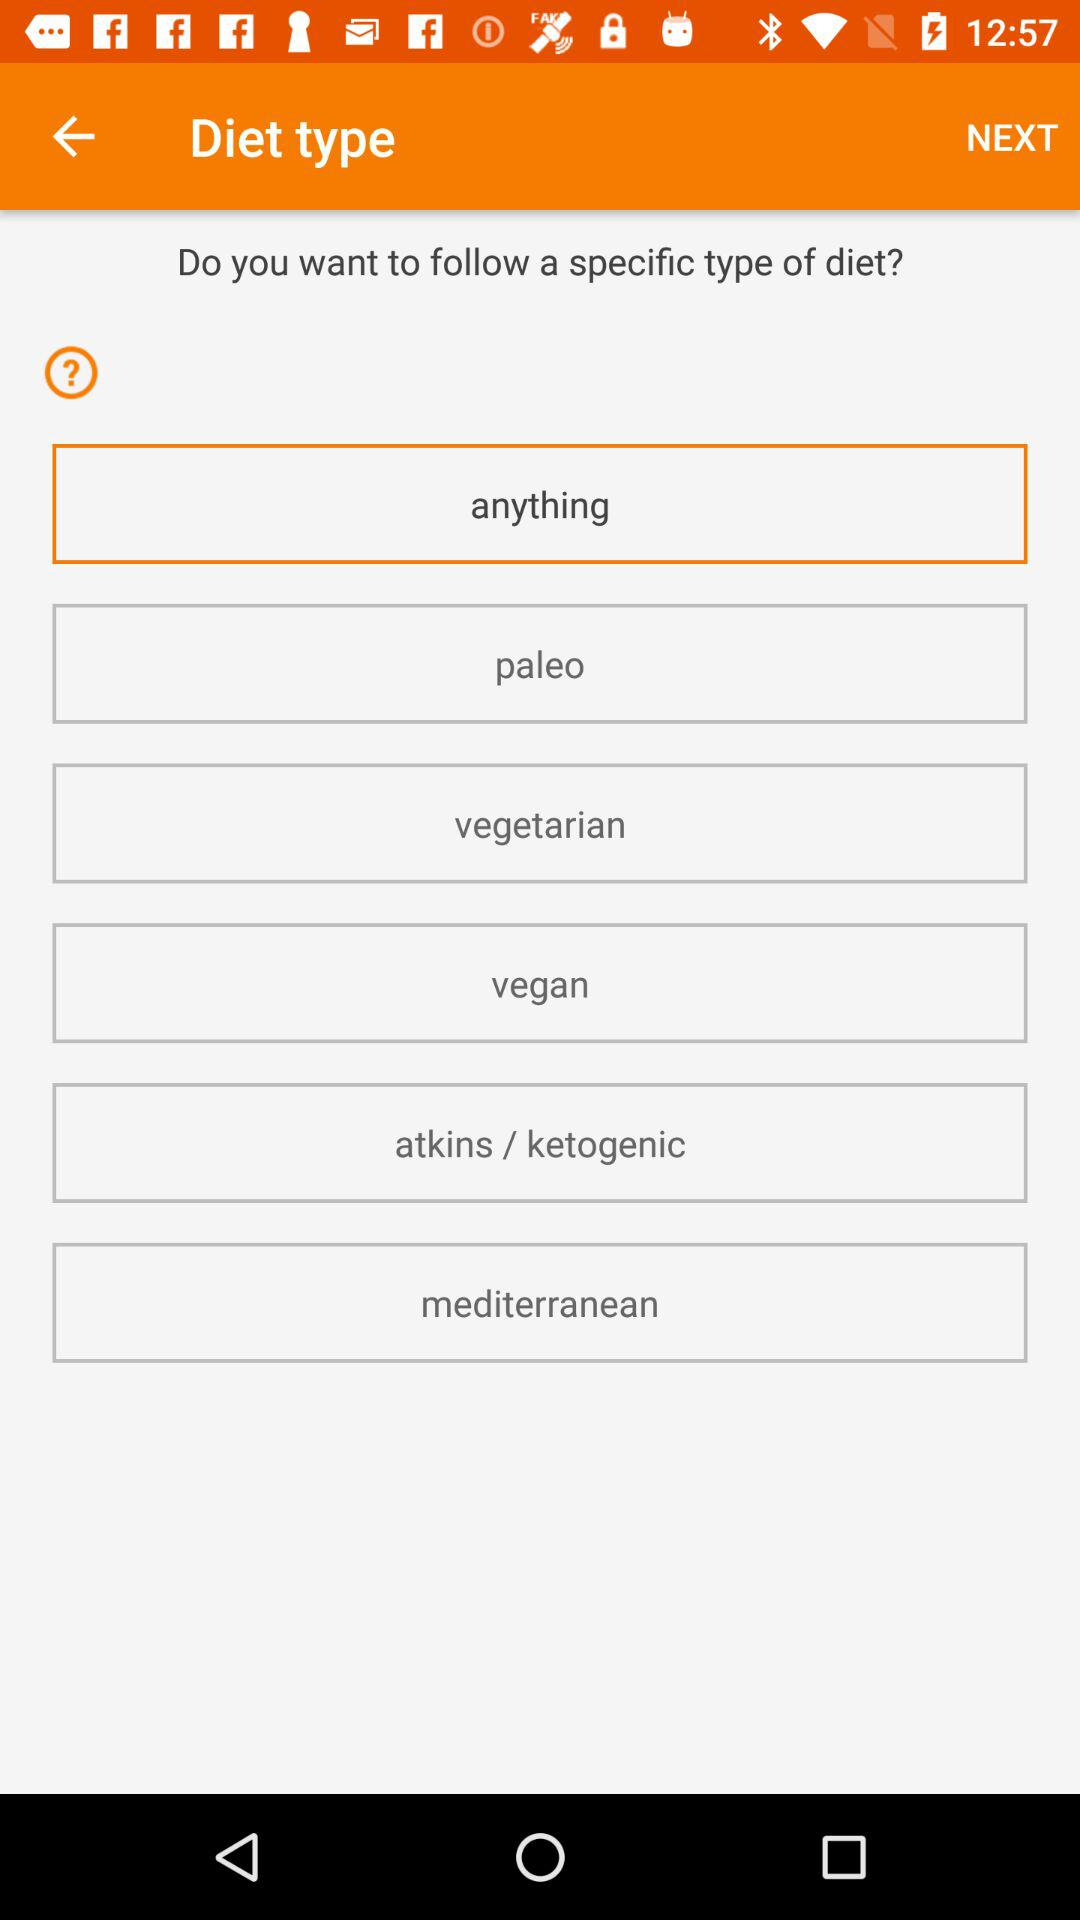What are the types of diets that I can choose? The types of diets are "paleo", "vegetarian", "vegan", "atkins / ketogenic" and "mediterranean". 